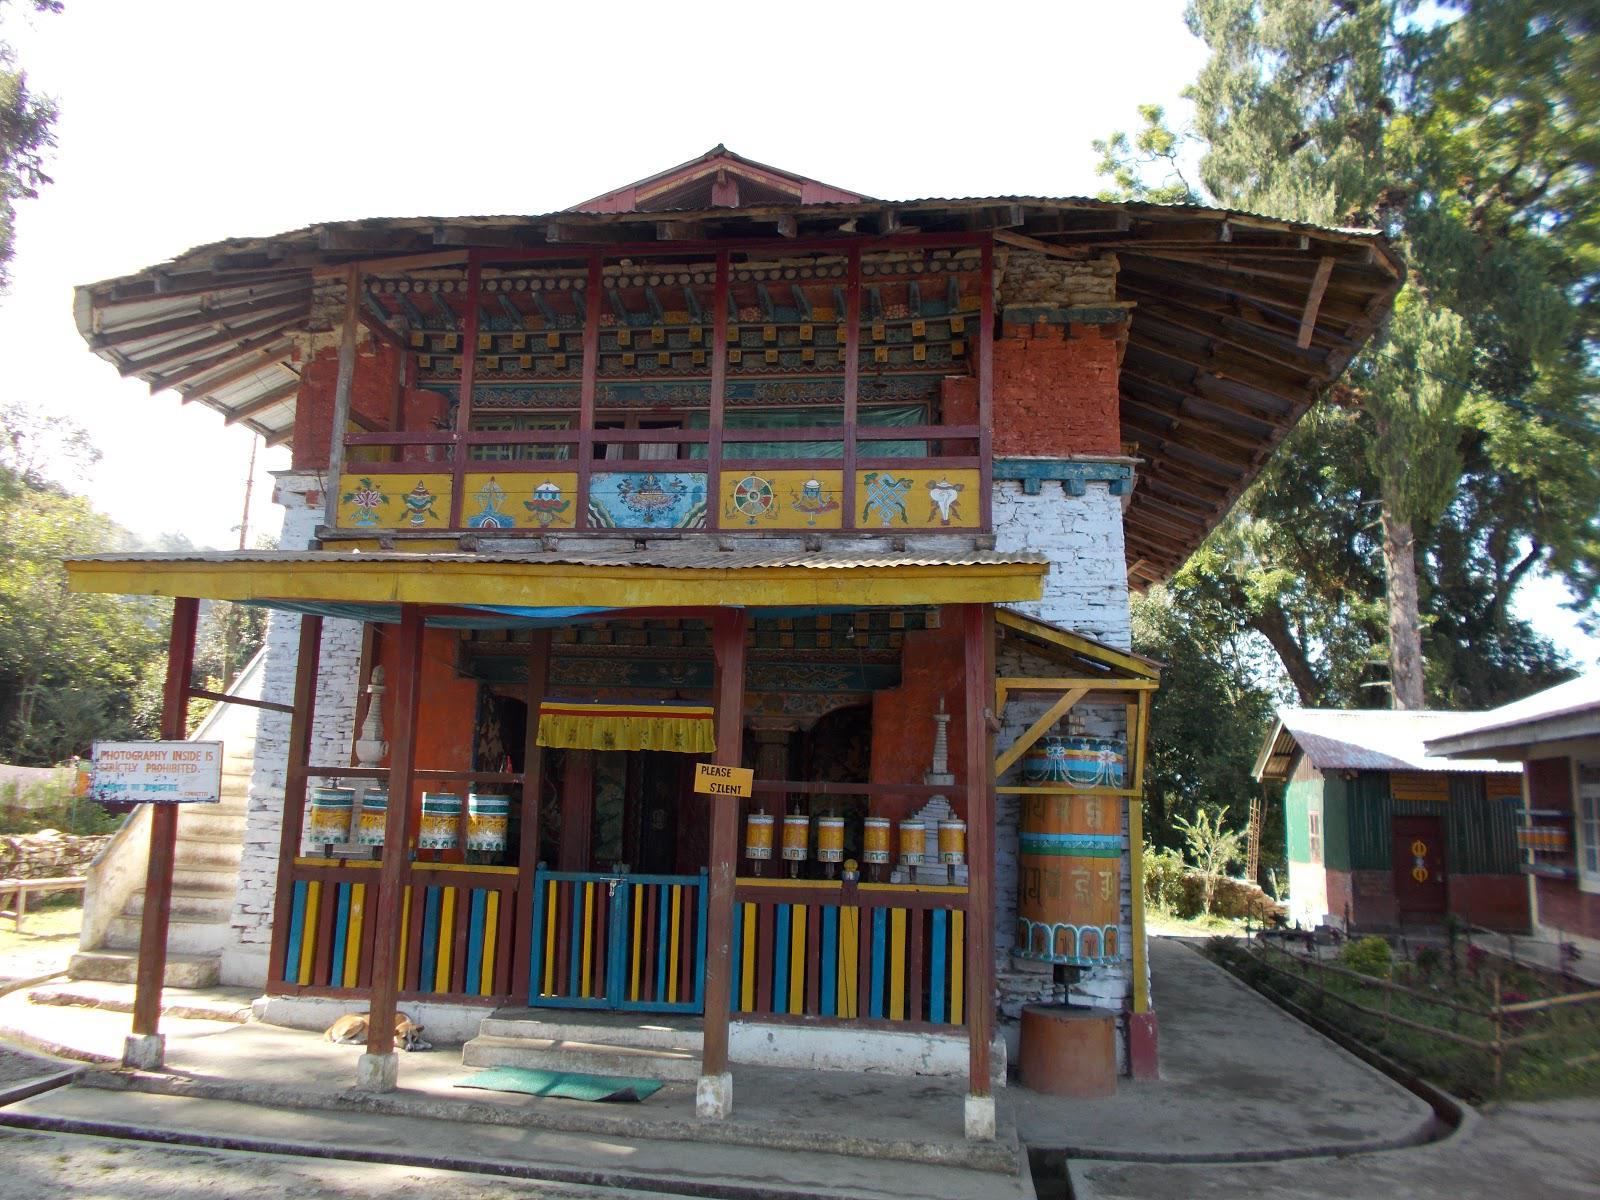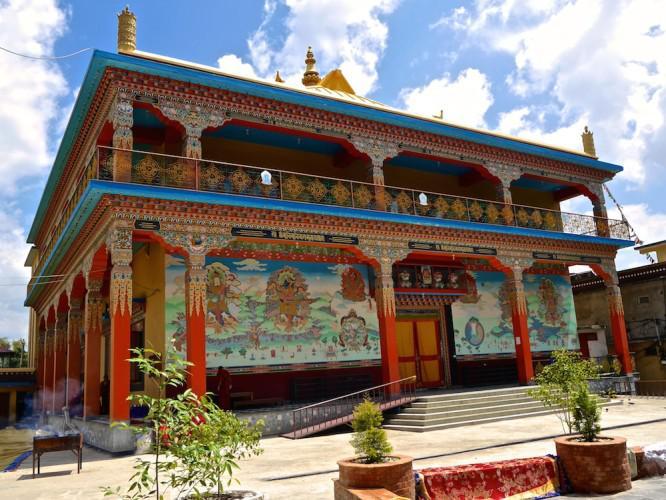The first image is the image on the left, the second image is the image on the right. Examine the images to the left and right. Is the description "There is at least one flag in front the building in at least one of the images." accurate? Answer yes or no. No. The first image is the image on the left, the second image is the image on the right. Considering the images on both sides, is "Each image shows an ornate building with a series of posts that support a roof hanging over a walkway that allows access to an entrance." valid? Answer yes or no. Yes. 